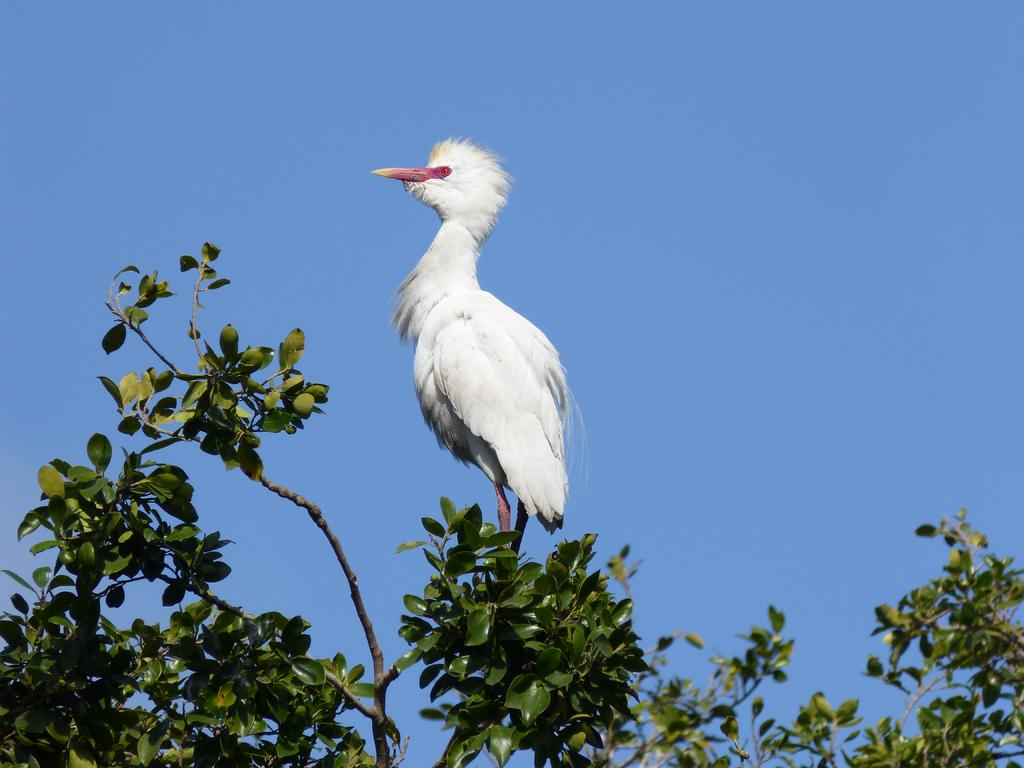What type of animal can be seen in the image? There is a bird in the image. Where is the bird located? The bird is standing on a tree. What can be seen in the background of the image? There is sky visible in the background of the image. What type of cabbage is the bird eating in the image? There is no cabbage present in the image, and the bird is not eating anything. 